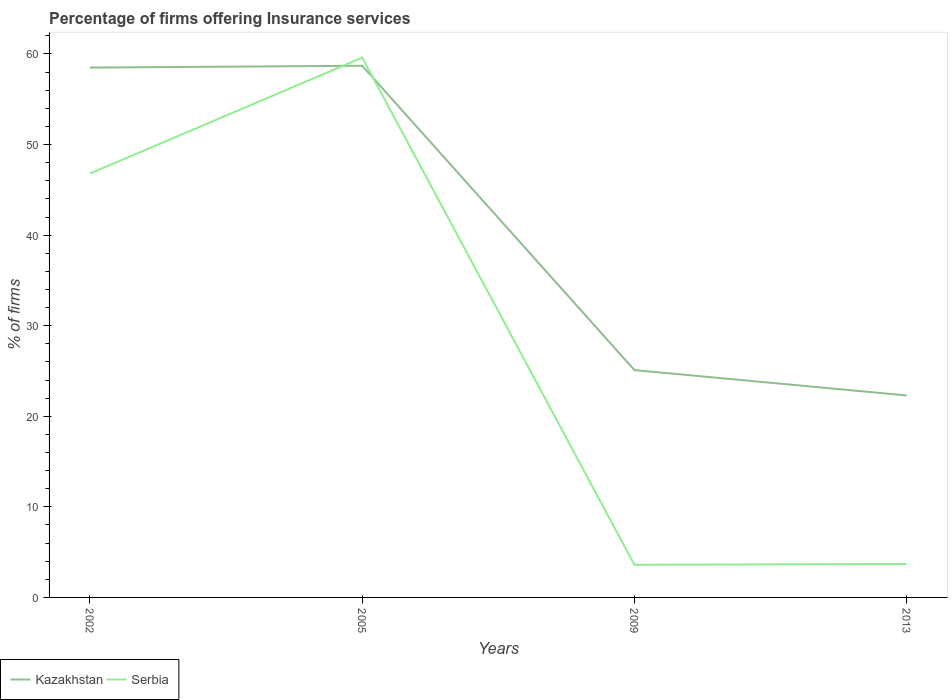How many different coloured lines are there?
Provide a succinct answer. 2. Is the number of lines equal to the number of legend labels?
Your answer should be compact. Yes. Across all years, what is the maximum percentage of firms offering insurance services in Kazakhstan?
Offer a very short reply. 22.3. In which year was the percentage of firms offering insurance services in Serbia maximum?
Your response must be concise. 2009. What is the total percentage of firms offering insurance services in Serbia in the graph?
Your response must be concise. 43.2. What is the difference between the highest and the second highest percentage of firms offering insurance services in Kazakhstan?
Give a very brief answer. 36.4. How many lines are there?
Keep it short and to the point. 2. How many years are there in the graph?
Offer a very short reply. 4. Does the graph contain any zero values?
Your answer should be compact. No. How many legend labels are there?
Offer a very short reply. 2. What is the title of the graph?
Your response must be concise. Percentage of firms offering Insurance services. Does "Myanmar" appear as one of the legend labels in the graph?
Make the answer very short. No. What is the label or title of the Y-axis?
Keep it short and to the point. % of firms. What is the % of firms in Kazakhstan in 2002?
Give a very brief answer. 58.5. What is the % of firms in Serbia in 2002?
Provide a succinct answer. 46.8. What is the % of firms of Kazakhstan in 2005?
Provide a succinct answer. 58.7. What is the % of firms in Serbia in 2005?
Your answer should be very brief. 59.6. What is the % of firms in Kazakhstan in 2009?
Provide a succinct answer. 25.1. What is the % of firms of Serbia in 2009?
Offer a terse response. 3.6. What is the % of firms in Kazakhstan in 2013?
Offer a very short reply. 22.3. What is the % of firms of Serbia in 2013?
Ensure brevity in your answer.  3.7. Across all years, what is the maximum % of firms of Kazakhstan?
Ensure brevity in your answer.  58.7. Across all years, what is the maximum % of firms in Serbia?
Keep it short and to the point. 59.6. Across all years, what is the minimum % of firms of Kazakhstan?
Keep it short and to the point. 22.3. Across all years, what is the minimum % of firms of Serbia?
Offer a very short reply. 3.6. What is the total % of firms in Kazakhstan in the graph?
Ensure brevity in your answer.  164.6. What is the total % of firms of Serbia in the graph?
Your answer should be very brief. 113.7. What is the difference between the % of firms of Kazakhstan in 2002 and that in 2005?
Ensure brevity in your answer.  -0.2. What is the difference between the % of firms of Serbia in 2002 and that in 2005?
Ensure brevity in your answer.  -12.8. What is the difference between the % of firms of Kazakhstan in 2002 and that in 2009?
Give a very brief answer. 33.4. What is the difference between the % of firms in Serbia in 2002 and that in 2009?
Offer a terse response. 43.2. What is the difference between the % of firms of Kazakhstan in 2002 and that in 2013?
Ensure brevity in your answer.  36.2. What is the difference between the % of firms of Serbia in 2002 and that in 2013?
Your response must be concise. 43.1. What is the difference between the % of firms in Kazakhstan in 2005 and that in 2009?
Your response must be concise. 33.6. What is the difference between the % of firms of Serbia in 2005 and that in 2009?
Offer a very short reply. 56. What is the difference between the % of firms in Kazakhstan in 2005 and that in 2013?
Make the answer very short. 36.4. What is the difference between the % of firms of Serbia in 2005 and that in 2013?
Keep it short and to the point. 55.9. What is the difference between the % of firms of Kazakhstan in 2009 and that in 2013?
Your response must be concise. 2.8. What is the difference between the % of firms in Kazakhstan in 2002 and the % of firms in Serbia in 2009?
Keep it short and to the point. 54.9. What is the difference between the % of firms of Kazakhstan in 2002 and the % of firms of Serbia in 2013?
Offer a terse response. 54.8. What is the difference between the % of firms of Kazakhstan in 2005 and the % of firms of Serbia in 2009?
Your answer should be compact. 55.1. What is the difference between the % of firms in Kazakhstan in 2009 and the % of firms in Serbia in 2013?
Your answer should be compact. 21.4. What is the average % of firms in Kazakhstan per year?
Give a very brief answer. 41.15. What is the average % of firms in Serbia per year?
Your answer should be compact. 28.43. What is the ratio of the % of firms in Kazakhstan in 2002 to that in 2005?
Provide a succinct answer. 1. What is the ratio of the % of firms of Serbia in 2002 to that in 2005?
Your answer should be compact. 0.79. What is the ratio of the % of firms of Kazakhstan in 2002 to that in 2009?
Ensure brevity in your answer.  2.33. What is the ratio of the % of firms of Kazakhstan in 2002 to that in 2013?
Your answer should be very brief. 2.62. What is the ratio of the % of firms in Serbia in 2002 to that in 2013?
Provide a short and direct response. 12.65. What is the ratio of the % of firms of Kazakhstan in 2005 to that in 2009?
Make the answer very short. 2.34. What is the ratio of the % of firms in Serbia in 2005 to that in 2009?
Keep it short and to the point. 16.56. What is the ratio of the % of firms in Kazakhstan in 2005 to that in 2013?
Your response must be concise. 2.63. What is the ratio of the % of firms in Serbia in 2005 to that in 2013?
Your answer should be compact. 16.11. What is the ratio of the % of firms in Kazakhstan in 2009 to that in 2013?
Provide a succinct answer. 1.13. What is the ratio of the % of firms in Serbia in 2009 to that in 2013?
Provide a succinct answer. 0.97. What is the difference between the highest and the second highest % of firms in Kazakhstan?
Keep it short and to the point. 0.2. What is the difference between the highest and the lowest % of firms of Kazakhstan?
Keep it short and to the point. 36.4. What is the difference between the highest and the lowest % of firms of Serbia?
Ensure brevity in your answer.  56. 